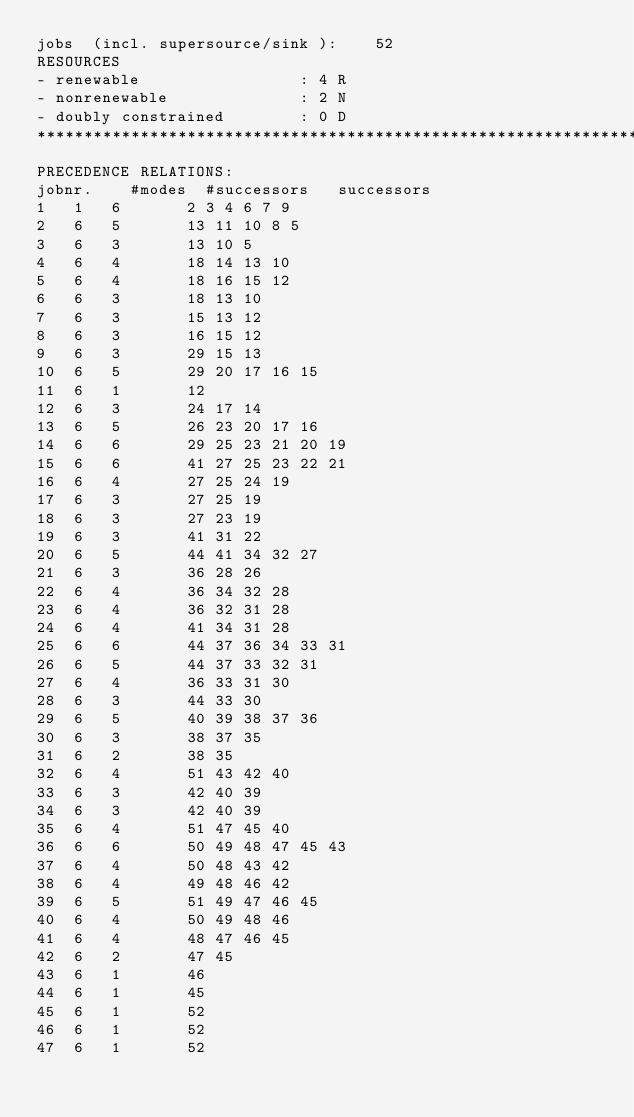Convert code to text. <code><loc_0><loc_0><loc_500><loc_500><_ObjectiveC_>jobs  (incl. supersource/sink ):	52
RESOURCES
- renewable                 : 4 R
- nonrenewable              : 2 N
- doubly constrained        : 0 D
************************************************************************
PRECEDENCE RELATIONS:
jobnr.    #modes  #successors   successors
1	1	6		2 3 4 6 7 9 
2	6	5		13 11 10 8 5 
3	6	3		13 10 5 
4	6	4		18 14 13 10 
5	6	4		18 16 15 12 
6	6	3		18 13 10 
7	6	3		15 13 12 
8	6	3		16 15 12 
9	6	3		29 15 13 
10	6	5		29 20 17 16 15 
11	6	1		12 
12	6	3		24 17 14 
13	6	5		26 23 20 17 16 
14	6	6		29 25 23 21 20 19 
15	6	6		41 27 25 23 22 21 
16	6	4		27 25 24 19 
17	6	3		27 25 19 
18	6	3		27 23 19 
19	6	3		41 31 22 
20	6	5		44 41 34 32 27 
21	6	3		36 28 26 
22	6	4		36 34 32 28 
23	6	4		36 32 31 28 
24	6	4		41 34 31 28 
25	6	6		44 37 36 34 33 31 
26	6	5		44 37 33 32 31 
27	6	4		36 33 31 30 
28	6	3		44 33 30 
29	6	5		40 39 38 37 36 
30	6	3		38 37 35 
31	6	2		38 35 
32	6	4		51 43 42 40 
33	6	3		42 40 39 
34	6	3		42 40 39 
35	6	4		51 47 45 40 
36	6	6		50 49 48 47 45 43 
37	6	4		50 48 43 42 
38	6	4		49 48 46 42 
39	6	5		51 49 47 46 45 
40	6	4		50 49 48 46 
41	6	4		48 47 46 45 
42	6	2		47 45 
43	6	1		46 
44	6	1		45 
45	6	1		52 
46	6	1		52 
47	6	1		52 </code> 